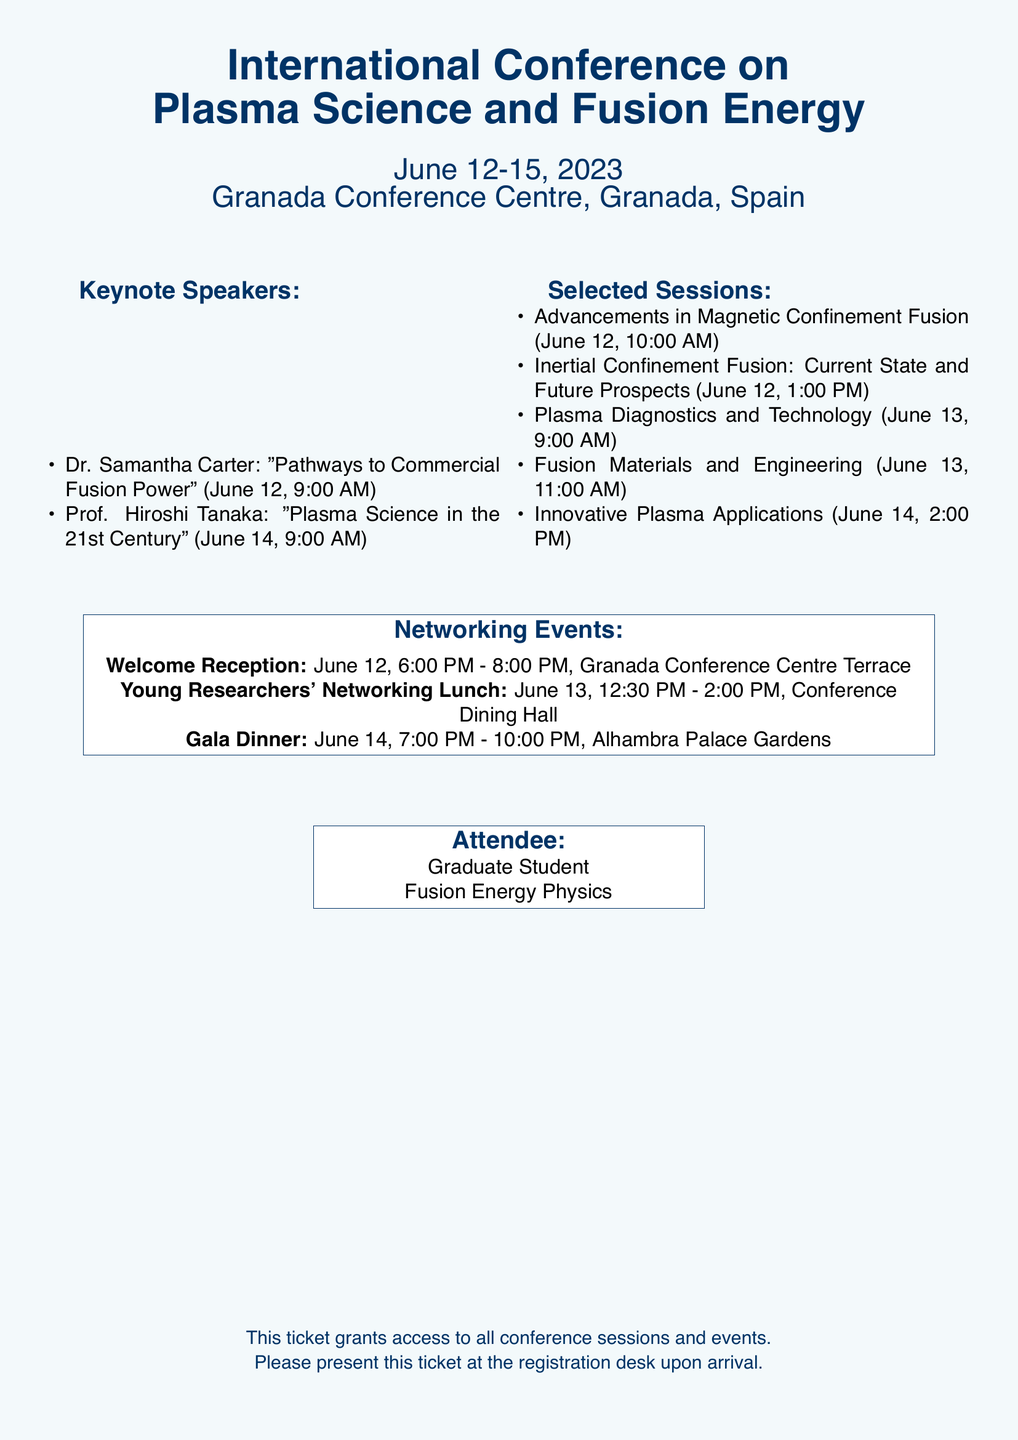What are the dates of the conference? The dates of the conference, mentioned at the beginning of the document, are from June 12 to June 15, 2023.
Answer: June 12-15, 2023 Who is the keynote speaker on June 14? The document lists Dr. Samantha Carter speaking on June 12 and highlights Prof. Hiroshi Tanaka for June 14.
Answer: Prof. Hiroshi Tanaka What sessions take place on June 12? The sessions listed for June 12 include "Advancements in Magnetic Confinement Fusion" and "Inertial Confinement Fusion: Current State and Future Prospects."
Answer: Advancements in Magnetic Confinement Fusion, Inertial Confinement Fusion: Current State and Future Prospects What is the location of the Welcome Reception? The document specifies that the Welcome Reception will take place at the Granada Conference Centre Terrace.
Answer: Granada Conference Centre Terrace How many networking events are listed? The document itemizes three distinct networking events scheduled during the conference.
Answer: Three What session is focused on “Fusion Materials and Engineering”? The session specifically focusing on “Fusion Materials and Engineering” is scheduled for June 13 at 11:00 AM.
Answer: Fusion Materials and Engineering What time does the Gala Dinner start? According to the document, the Gala Dinner starts at 7:00 PM on June 14.
Answer: 7:00 PM What is the format of this document? The document is formatted as a ticket granting access to the conference sessions and events.
Answer: Ticket 